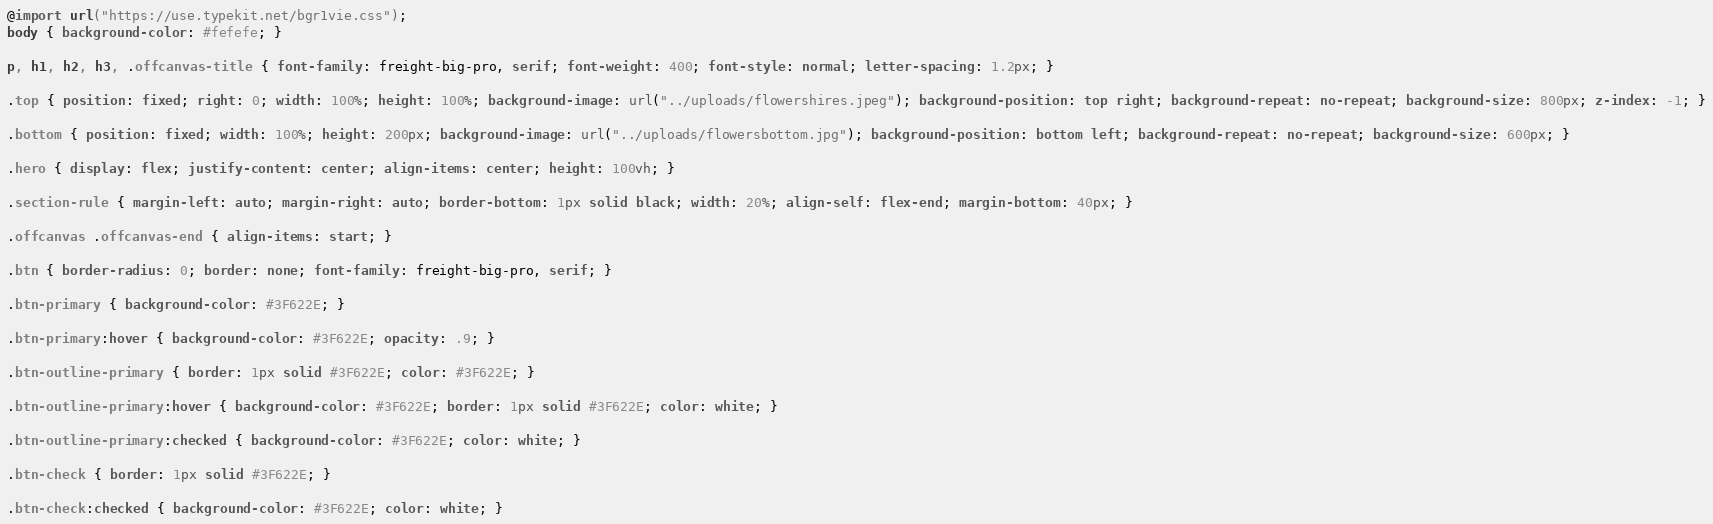<code> <loc_0><loc_0><loc_500><loc_500><_CSS_>@import url("https://use.typekit.net/bgr1vie.css");
body { background-color: #fefefe; }

p, h1, h2, h3, .offcanvas-title { font-family: freight-big-pro, serif; font-weight: 400; font-style: normal; letter-spacing: 1.2px; }

.top { position: fixed; right: 0; width: 100%; height: 100%; background-image: url("../uploads/flowershires.jpeg"); background-position: top right; background-repeat: no-repeat; background-size: 800px; z-index: -1; }

.bottom { position: fixed; width: 100%; height: 200px; background-image: url("../uploads/flowersbottom.jpg"); background-position: bottom left; background-repeat: no-repeat; background-size: 600px; }

.hero { display: flex; justify-content: center; align-items: center; height: 100vh; }

.section-rule { margin-left: auto; margin-right: auto; border-bottom: 1px solid black; width: 20%; align-self: flex-end; margin-bottom: 40px; }

.offcanvas .offcanvas-end { align-items: start; }

.btn { border-radius: 0; border: none; font-family: freight-big-pro, serif; }

.btn-primary { background-color: #3F622E; }

.btn-primary:hover { background-color: #3F622E; opacity: .9; }

.btn-outline-primary { border: 1px solid #3F622E; color: #3F622E; }

.btn-outline-primary:hover { background-color: #3F622E; border: 1px solid #3F622E; color: white; }

.btn-outline-primary:checked { background-color: #3F622E; color: white; }

.btn-check { border: 1px solid #3F622E; }

.btn-check:checked { background-color: #3F622E; color: white; }
</code> 